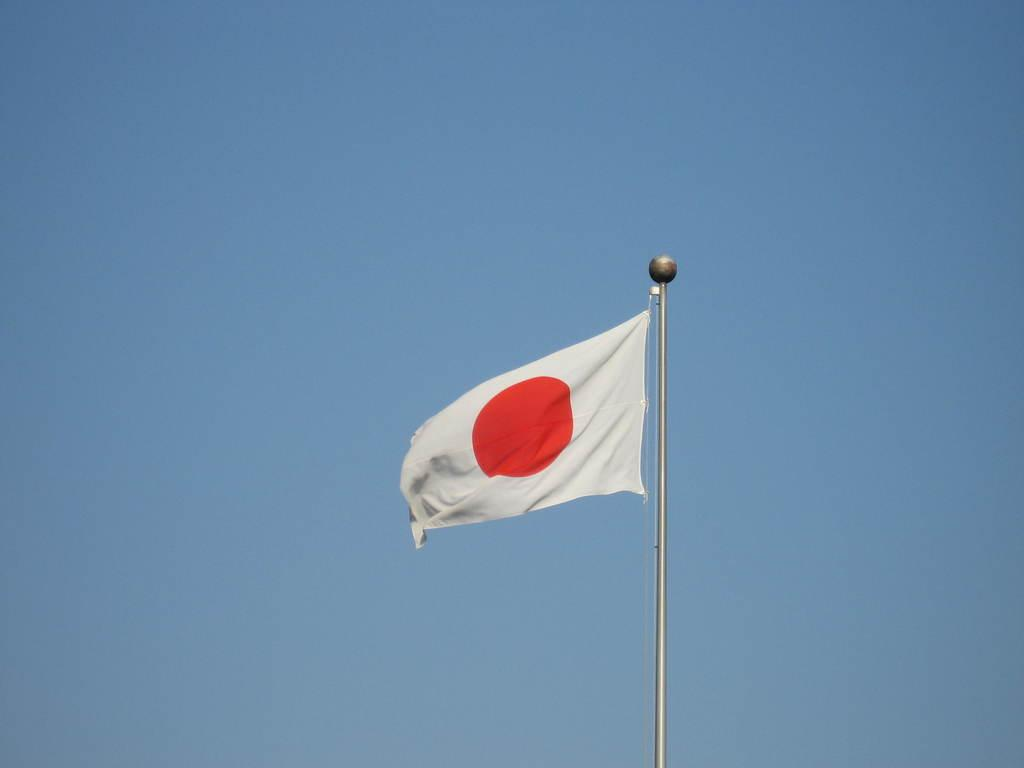What is present in the image that represents a country or organization? There is a flag in the image. What is the color of the flag? The flag is white in color. Are there any symbols or designs on the flag? Yes, there is a red circle on the flag. How many sheep can be seen inside the cave in the image? There are no sheep or caves present in the image; it only features a flag with a red circle on it. 